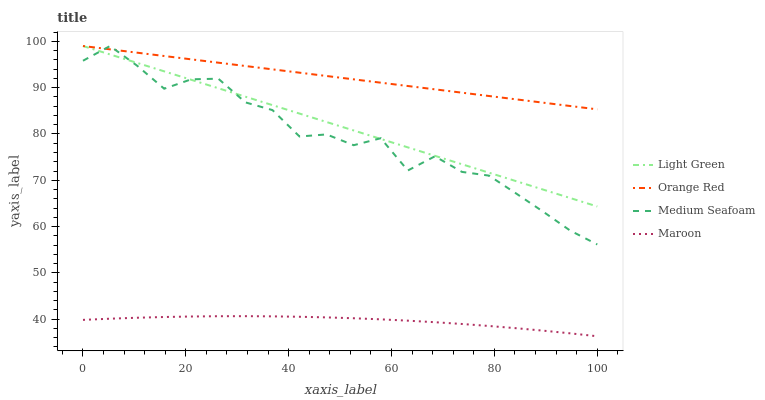Does Maroon have the minimum area under the curve?
Answer yes or no. Yes. Does Orange Red have the maximum area under the curve?
Answer yes or no. Yes. Does Light Green have the minimum area under the curve?
Answer yes or no. No. Does Light Green have the maximum area under the curve?
Answer yes or no. No. Is Orange Red the smoothest?
Answer yes or no. Yes. Is Medium Seafoam the roughest?
Answer yes or no. Yes. Is Light Green the smoothest?
Answer yes or no. No. Is Light Green the roughest?
Answer yes or no. No. Does Light Green have the lowest value?
Answer yes or no. No. Does Medium Seafoam have the highest value?
Answer yes or no. Yes. Is Maroon less than Light Green?
Answer yes or no. Yes. Is Medium Seafoam greater than Maroon?
Answer yes or no. Yes. Does Orange Red intersect Light Green?
Answer yes or no. Yes. Is Orange Red less than Light Green?
Answer yes or no. No. Is Orange Red greater than Light Green?
Answer yes or no. No. Does Maroon intersect Light Green?
Answer yes or no. No. 